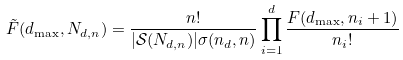<formula> <loc_0><loc_0><loc_500><loc_500>\tilde { F } ( d _ { \max } , N _ { d , n } ) = \frac { n ! } { | \mathcal { S } ( N _ { d , n } ) | \sigma ( n _ { d } , n ) } \prod _ { i = 1 } ^ { d } \frac { F ( d _ { \max } , n _ { i } + 1 ) } { n _ { i } ! } \,</formula> 